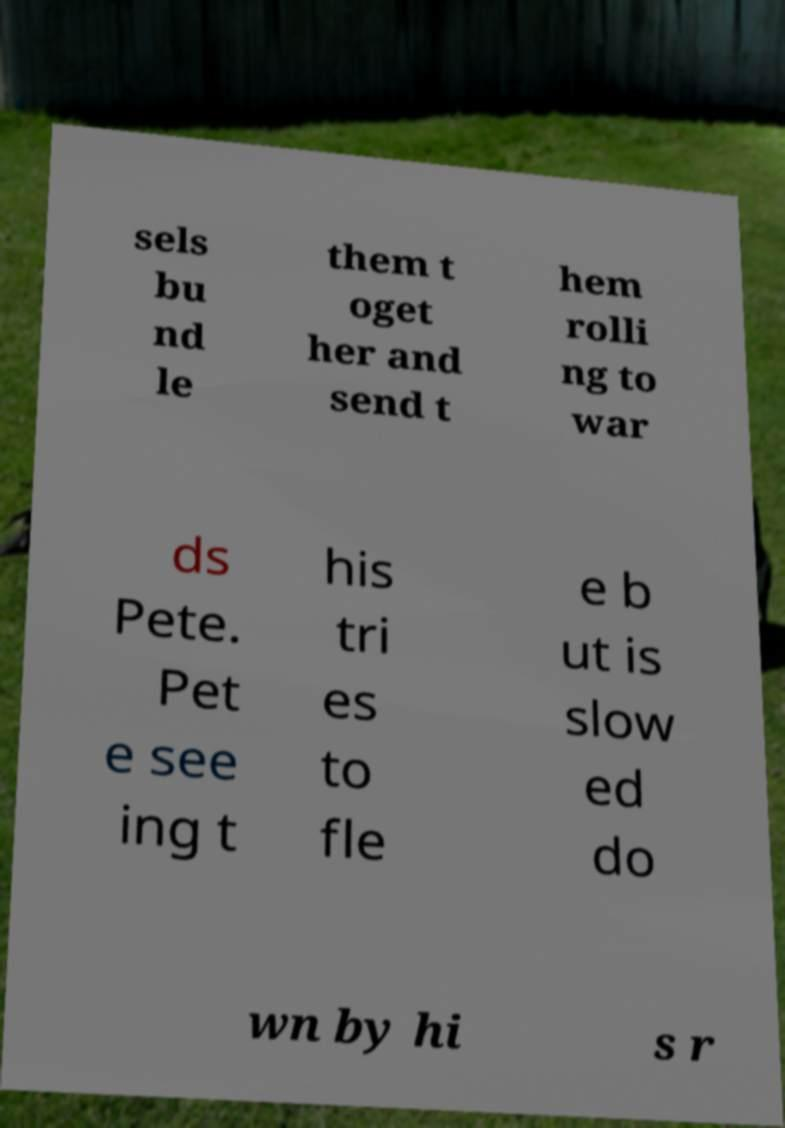Could you assist in decoding the text presented in this image and type it out clearly? sels bu nd le them t oget her and send t hem rolli ng to war ds Pete. Pet e see ing t his tri es to fle e b ut is slow ed do wn by hi s r 